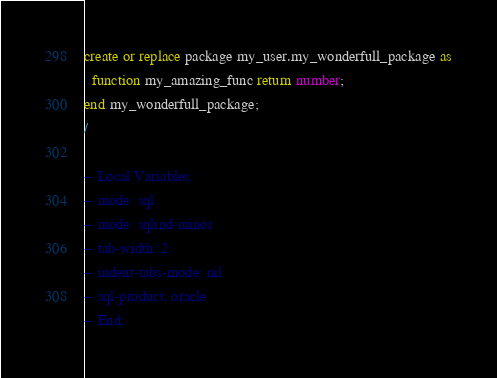<code> <loc_0><loc_0><loc_500><loc_500><_SQL_>create or replace package my_user.my_wonderfull_package as
  function my_amazing_func return number;
end my_wonderfull_package;
/

-- Local Variables:
-- mode: sql
-- mode: sqlind-minor
-- tab-width: 2
-- indent-tabs-mode: nil
-- sql-product: oracle
-- End:
</code> 